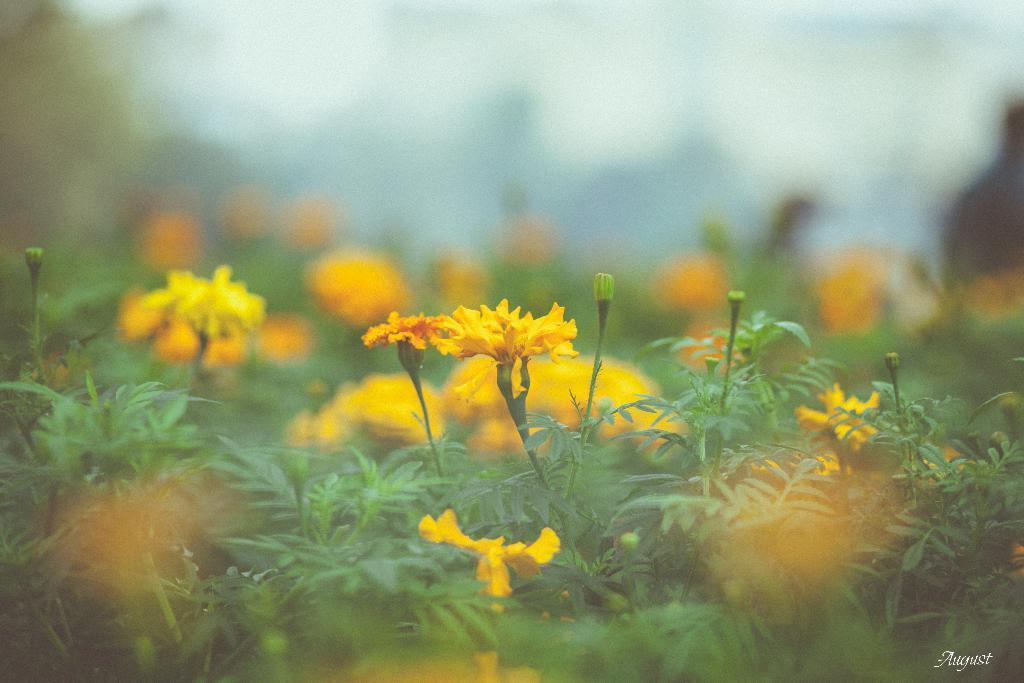How would you summarize this image in a sentence or two? In this picture I can see the plants in front on which there are flowers, which are of yellow color. I see that it is blurred in the background. On the right bottom corner of this image I can see the watermark. 